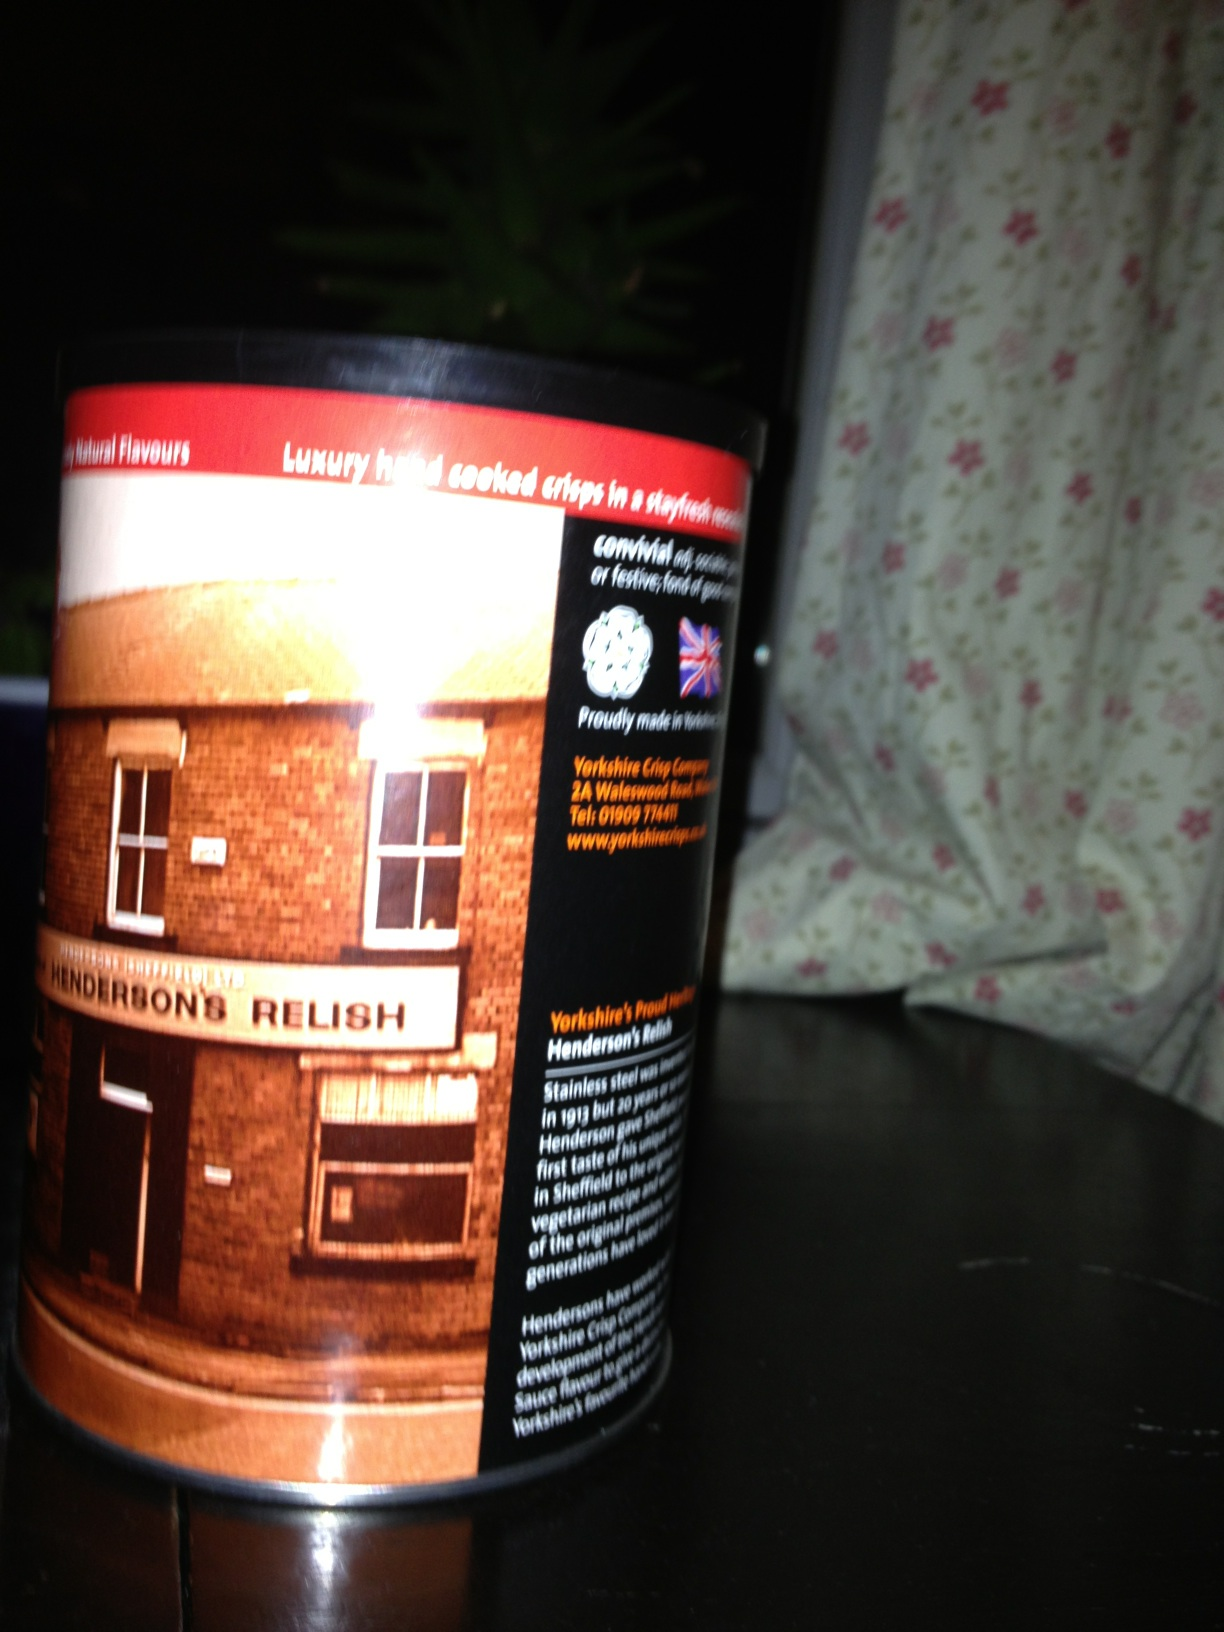Can you describe the historical importance of Henderson's Relish? Henderson's Relish, often affectionately known as 'Hendo's' by locals, has been a staple in Sheffield since the late 19th century. The recipe is a closely guarded secret, known only to a few, and its rich, tangy flavor has been cherished by generations. The relish holds a special place in local cuisine, being versatile enough to enhance a wide variety of dishes. Its importance extends beyond just a condiment; it's a symbol of local pride and cultural heritage for the people of Sheffield. What are some traditional uses for Henderson's Relish? Traditionally, Henderson's Relish is used as a seasoning for pies, stews, and soups, lending a distinctive flavor to these hearty dishes. It is also commonly drizzled over fish and chips, beans on toast, and shepherd’s pie. The versatility of the relish means it can be used in marinades, dressings, and even some unconventional recipes like spicy cocktails or gourmet popcorn, allowing it to add depth and complexity to both traditional and modern culinary creations. 